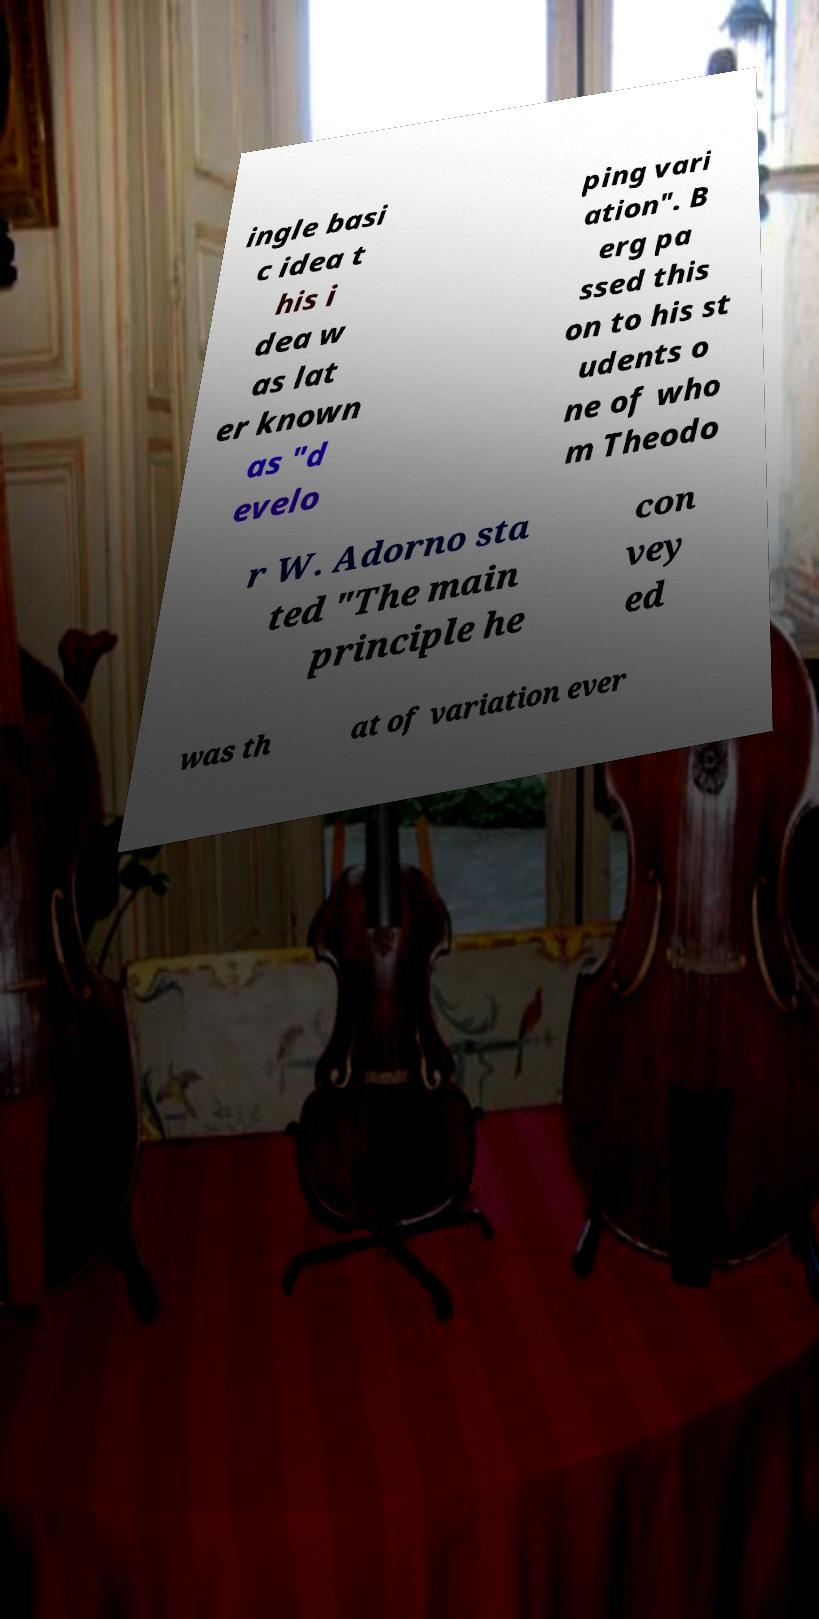What messages or text are displayed in this image? I need them in a readable, typed format. ingle basi c idea t his i dea w as lat er known as "d evelo ping vari ation". B erg pa ssed this on to his st udents o ne of who m Theodo r W. Adorno sta ted "The main principle he con vey ed was th at of variation ever 